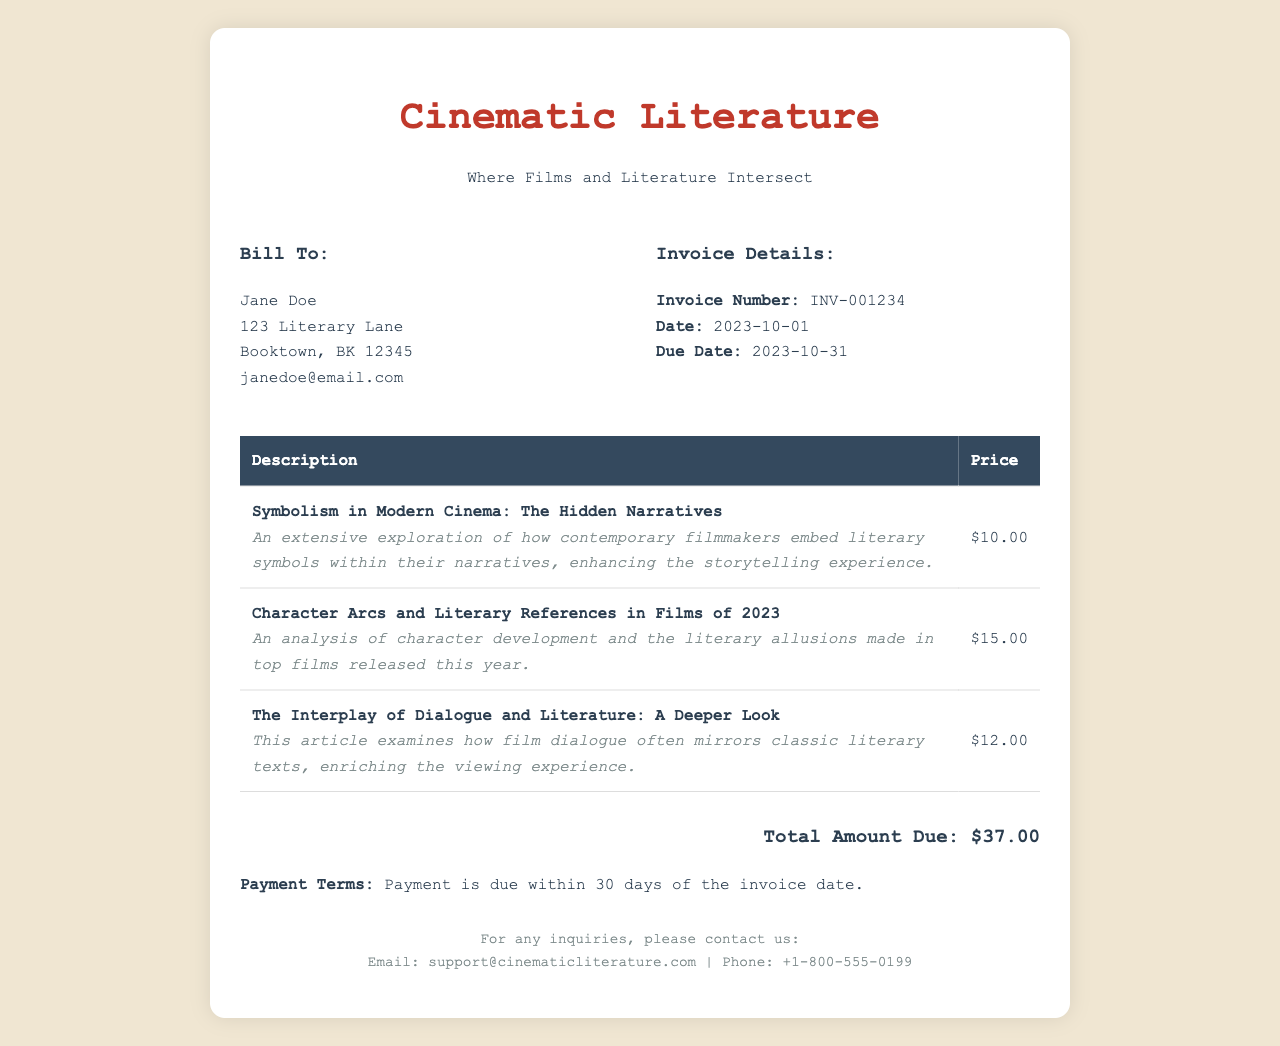What is the invoice number? The invoice number is clearly stated in the "Invoice Details" section.
Answer: INV-001234 Who is billed for the subscription? The billing information section lists the name of the person billed.
Answer: Jane Doe What is the due date for payment? The due date is provided in the "Invoice Details" section.
Answer: 2023-10-31 How many articles are listed in the invoice? The number of articles can be counted from the table provided.
Answer: 3 What is the total amount due? The total amount is prominently displayed in the "Total Amount Due" section.
Answer: $37.00 What is the feature description for the first article? This description elaborates on the contents of the first item in the table.
Answer: An extensive exploration of how contemporary filmmakers embed literary symbols within their narratives, enhancing the storytelling experience What payment terms are specified? The payment terms are noted directly under the total amount due.
Answer: Payment is due within 30 days of the invoice date What is the email contact for inquiries? The email for inquiries is provided in the footer section.
Answer: support@cinematicliterature.com 